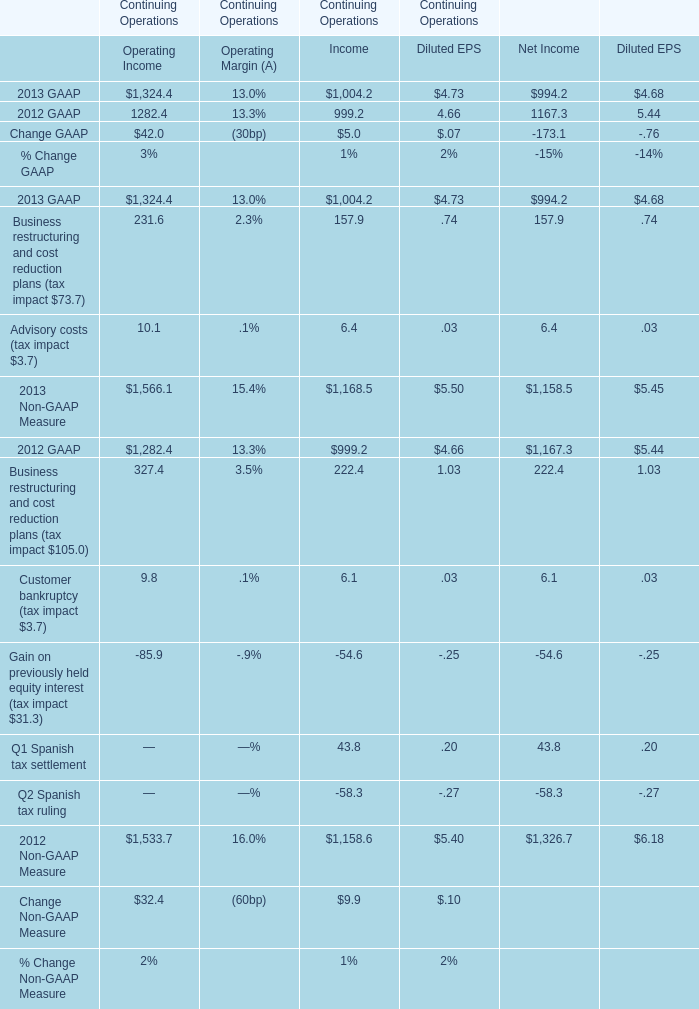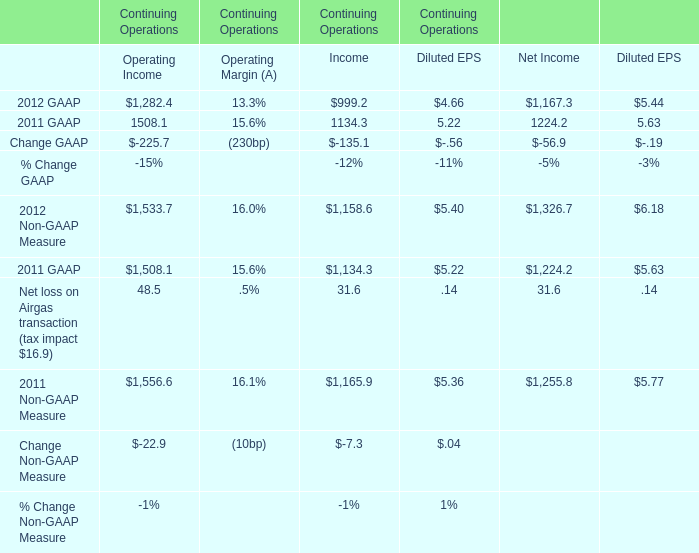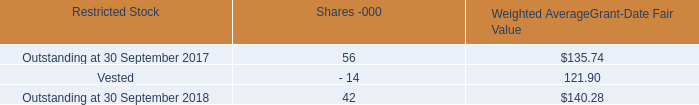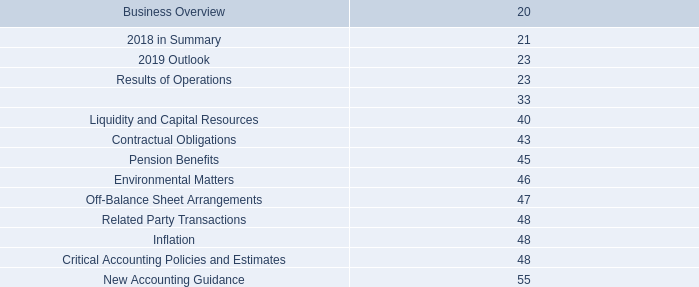What's the total amount of 2013 GAAP: Continuing Operations in the range of 1000 and 1500 in 2013? 
Computations: (1324.4 + 1004.2)
Answer: 2328.6. 